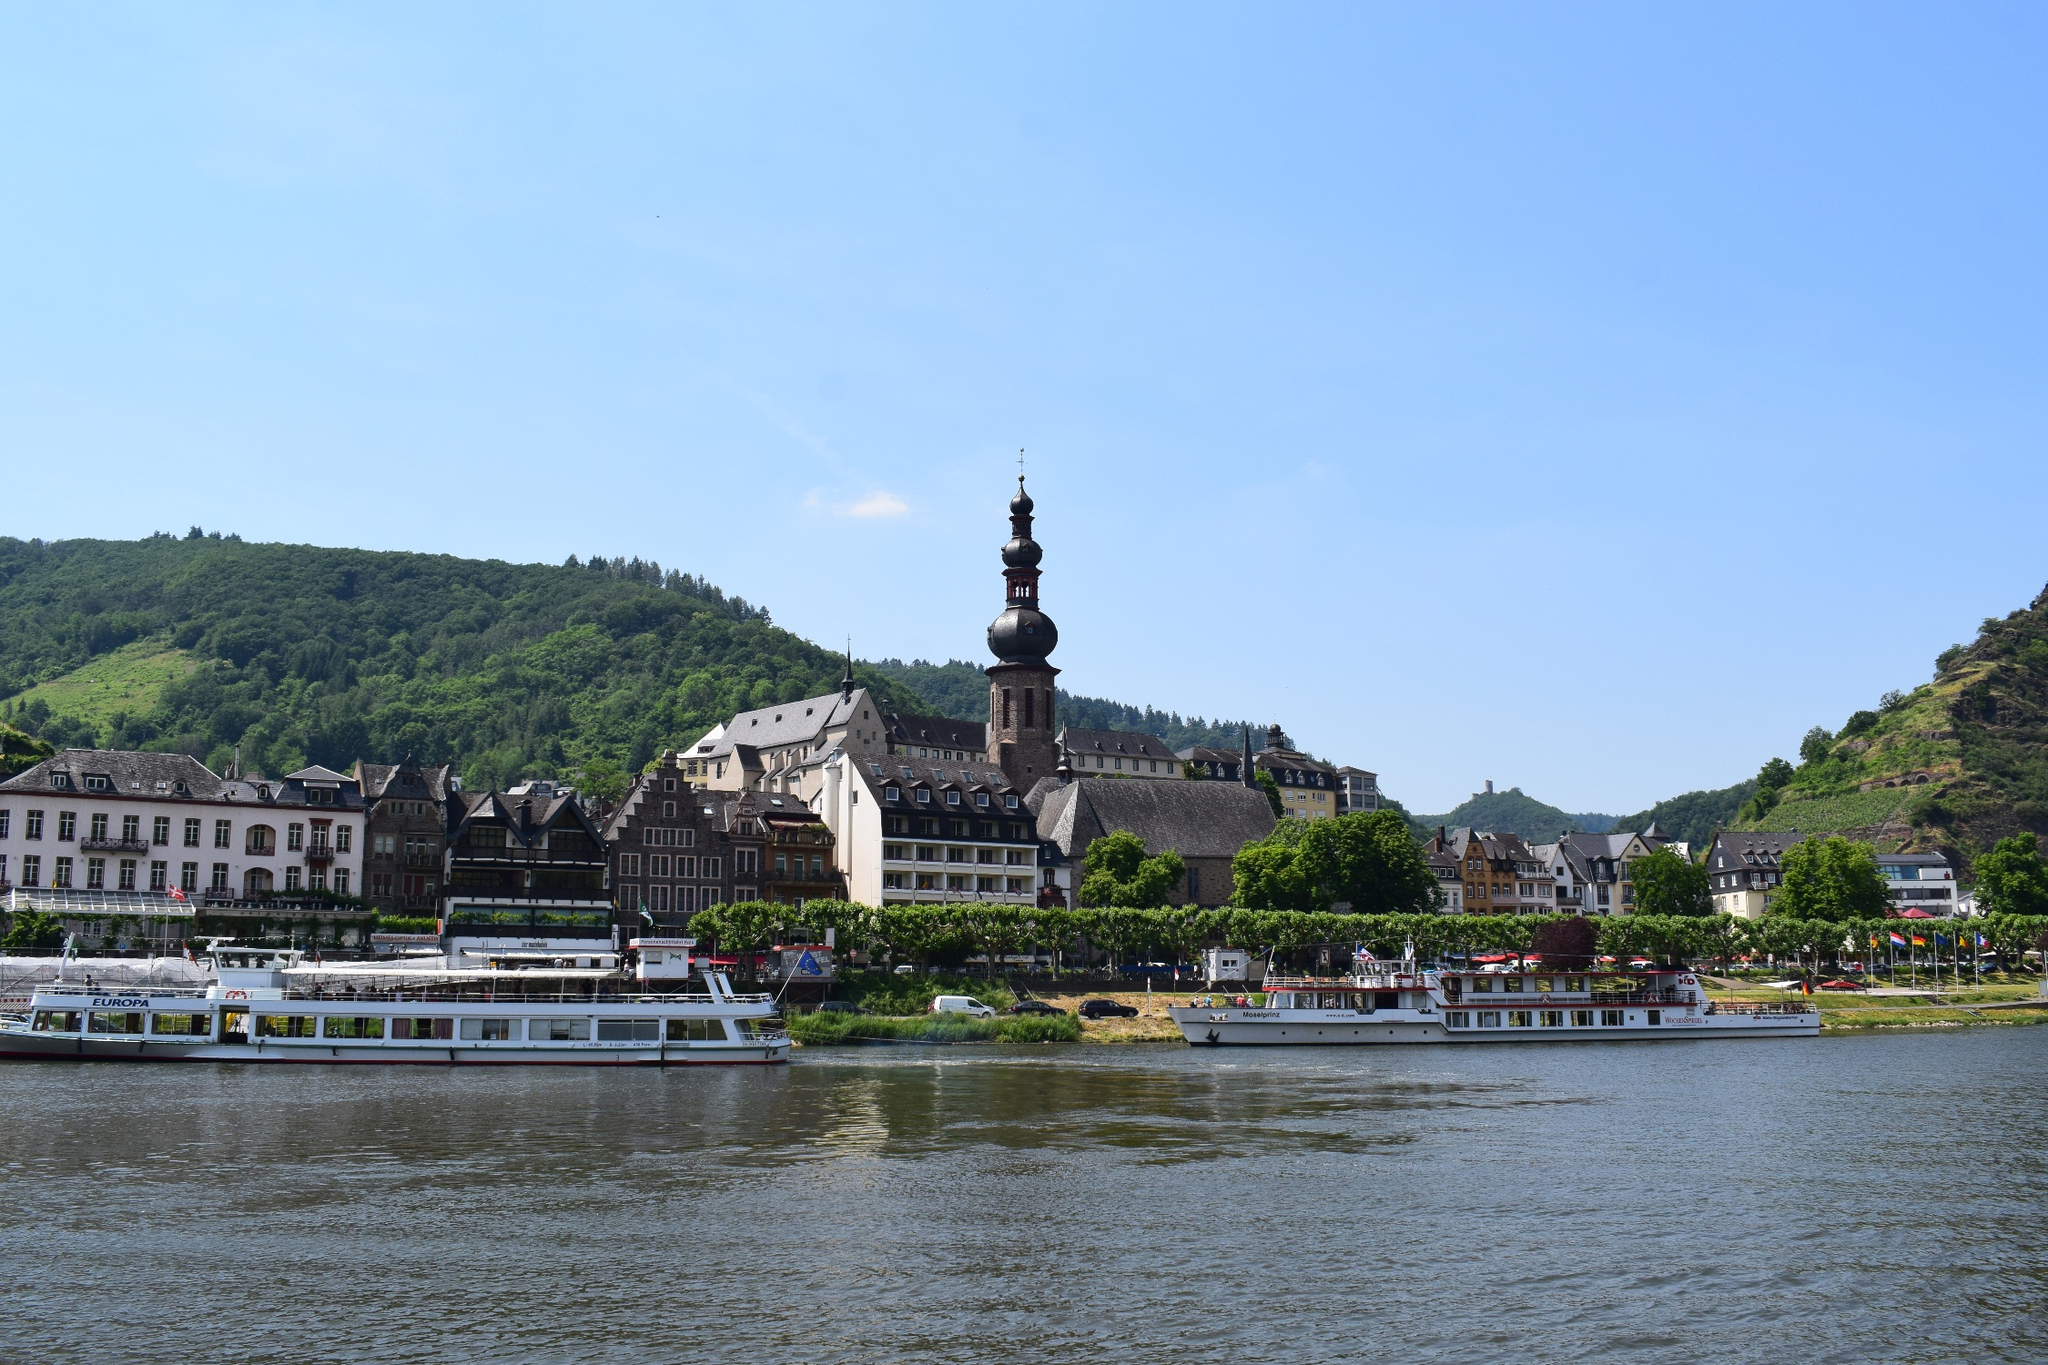What time of year does it appear to be in this photo? Based on the vibrant green foliage on the hills and the people seen outdoors in light clothing, it seems to be taken during the warmer months, likely late spring or summer. The presence of a riverboat with passengers also suggests that it's a period conducive to tourism, which peaks during these seasons. The sky is clear, and there is no visible snow or barren trees, supporting the assessment of a season of pleasant weather. 